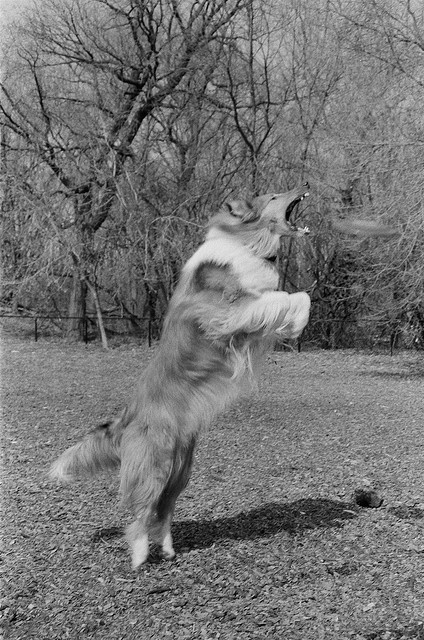Describe the objects in this image and their specific colors. I can see dog in lightgray, darkgray, gray, and black tones and frisbee in gray, black, and lightgray tones in this image. 